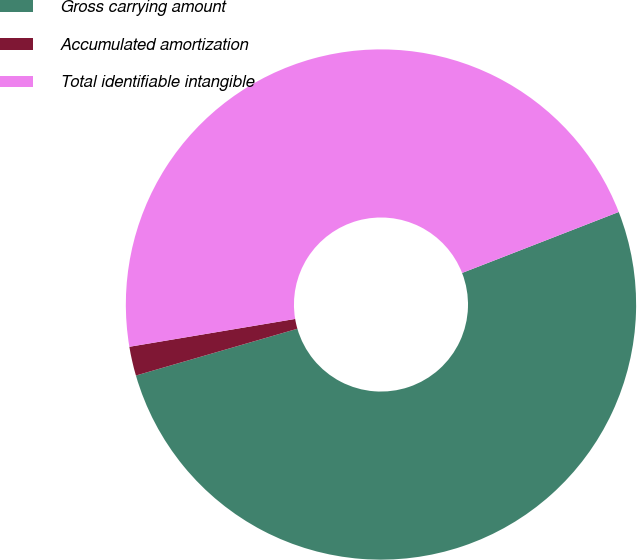<chart> <loc_0><loc_0><loc_500><loc_500><pie_chart><fcel>Gross carrying amount<fcel>Accumulated amortization<fcel>Total identifiable intangible<nl><fcel>51.42%<fcel>1.84%<fcel>46.74%<nl></chart> 